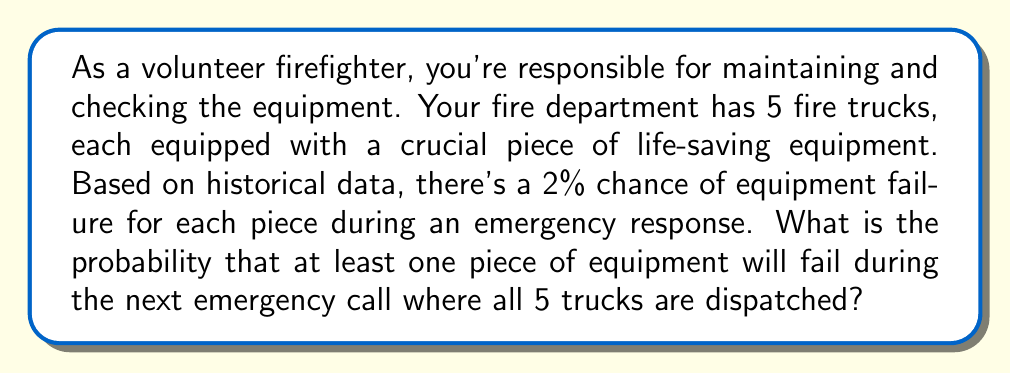Can you solve this math problem? Let's approach this step-by-step:

1) First, we need to find the probability of all equipment working correctly. For each piece of equipment:

   $P(\text{working}) = 1 - P(\text{failure}) = 1 - 0.02 = 0.98$

2) For all 5 pieces to work, each must work independently. We multiply the individual probabilities:

   $P(\text{all working}) = 0.98^5 = 0.9039$

3) The probability of at least one failure is the complement of all working:

   $P(\text{at least one failure}) = 1 - P(\text{all working})$
   $= 1 - 0.9039 = 0.0961$

4) Convert to percentage:

   $0.0961 \times 100\% = 9.61\%$

This result means there's about a 9.61% chance of at least one equipment failure during the next emergency call where all 5 trucks are dispatched.
Answer: The probability of at least one piece of equipment failing during the next emergency call is approximately 9.61% or 0.0961. 